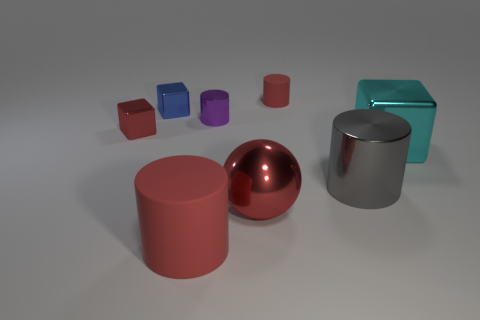Add 1 big cyan cubes. How many objects exist? 9 Subtract 1 cylinders. How many cylinders are left? 3 Add 6 green balls. How many green balls exist? 6 Subtract all purple cylinders. How many cylinders are left? 3 Subtract all large red cylinders. How many cylinders are left? 3 Subtract 1 red spheres. How many objects are left? 7 Subtract all spheres. How many objects are left? 7 Subtract all red cubes. Subtract all green spheres. How many cubes are left? 2 Subtract all brown cylinders. How many cyan cubes are left? 1 Subtract all gray objects. Subtract all tiny red cylinders. How many objects are left? 6 